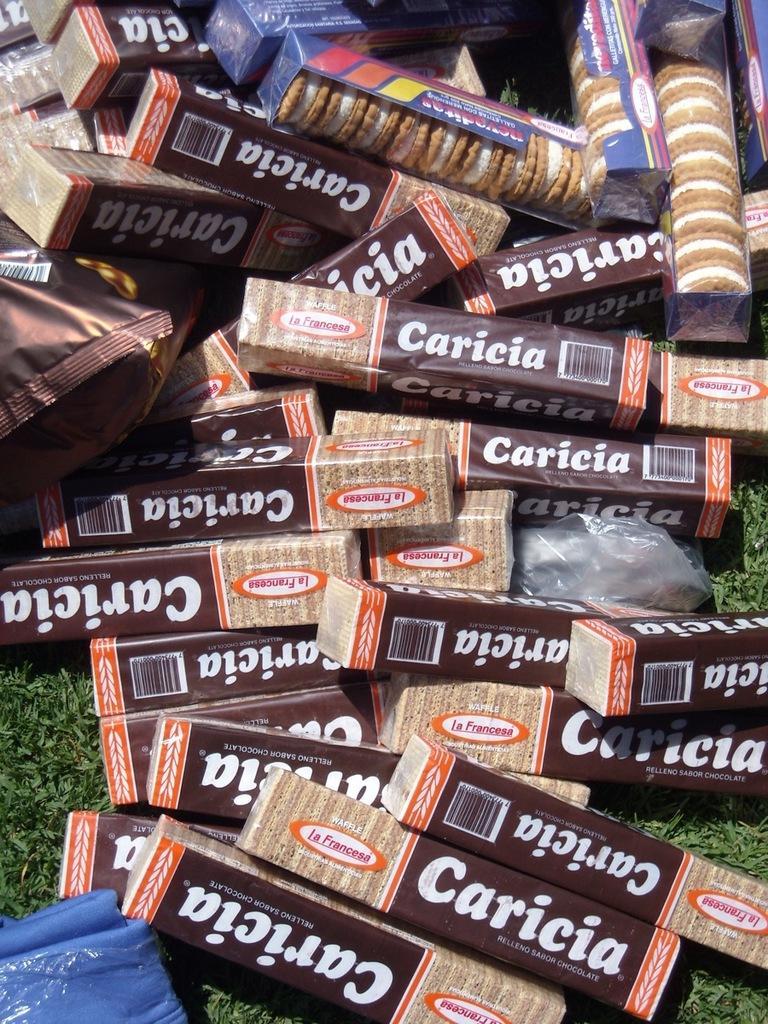Describe this image in one or two sentences. In this picture we can see boxes with cream biscuits in it, packets on grass. 